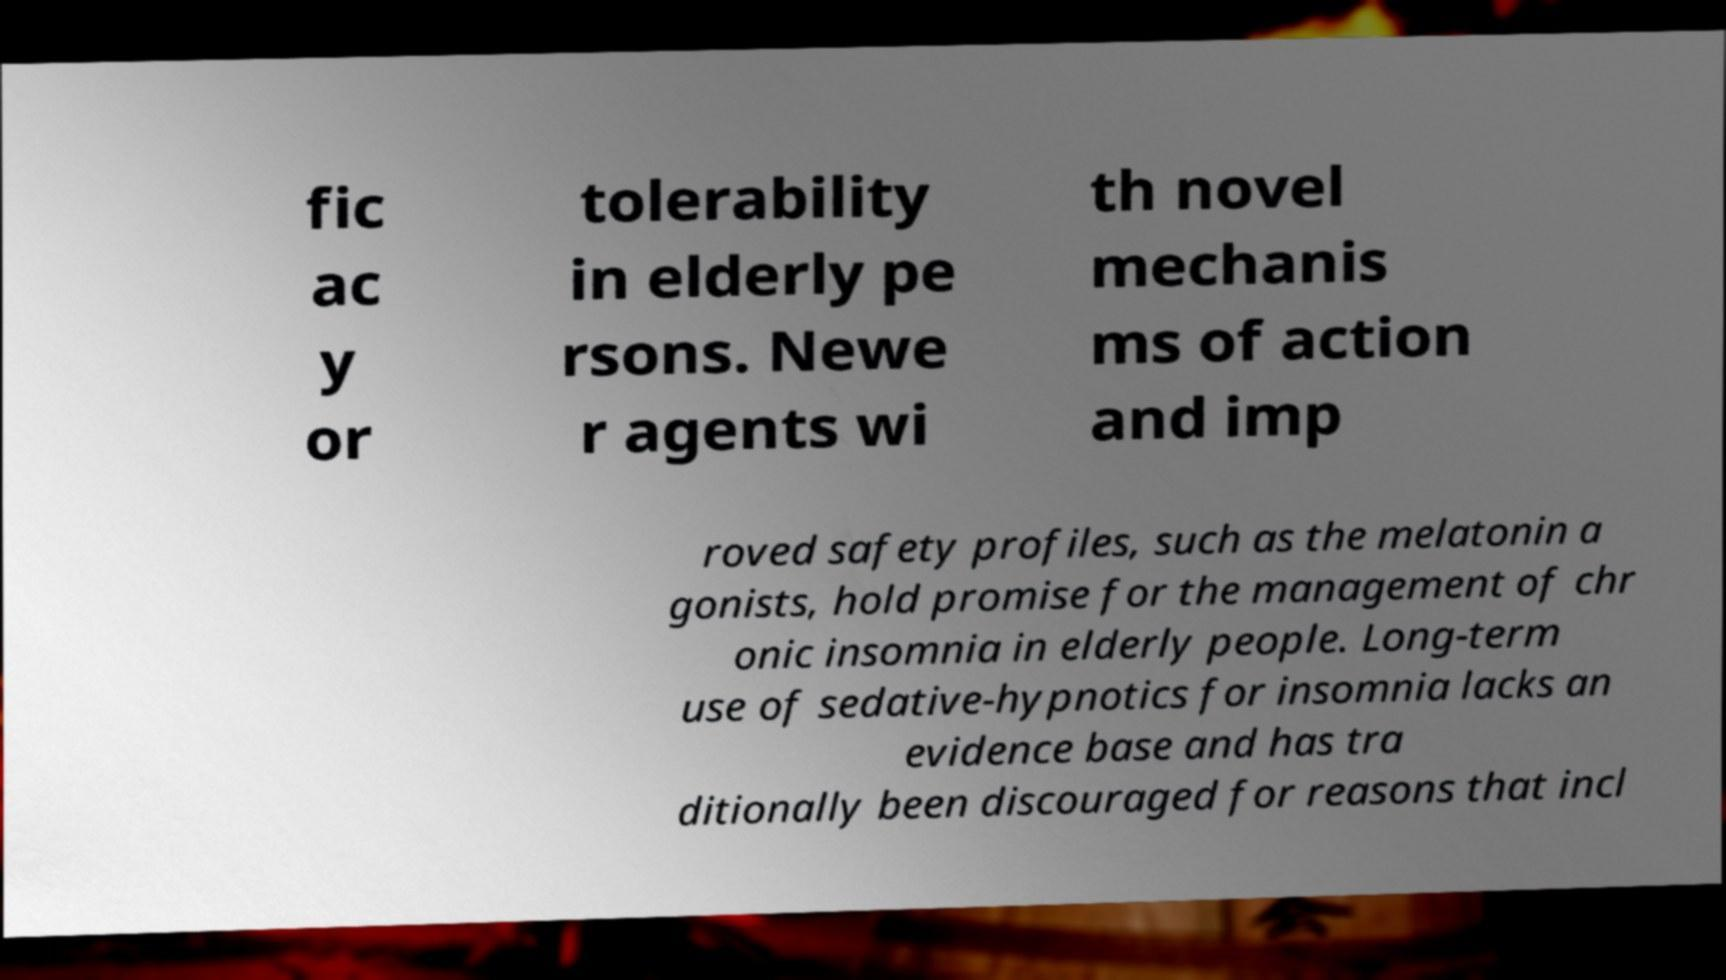What messages or text are displayed in this image? I need them in a readable, typed format. fic ac y or tolerability in elderly pe rsons. Newe r agents wi th novel mechanis ms of action and imp roved safety profiles, such as the melatonin a gonists, hold promise for the management of chr onic insomnia in elderly people. Long-term use of sedative-hypnotics for insomnia lacks an evidence base and has tra ditionally been discouraged for reasons that incl 